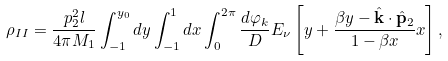<formula> <loc_0><loc_0><loc_500><loc_500>\rho _ { I I } = \frac { p _ { 2 } ^ { 2 } l } { 4 \pi M _ { 1 } } \int _ { - 1 } ^ { y _ { 0 } } d y \int _ { - 1 } ^ { 1 } d x \int _ { 0 } ^ { 2 \pi } \frac { d \varphi _ { k } } { D } E _ { \nu } \left [ y + \frac { \beta y - { \hat { \mathbf k } } \cdot { \hat { \mathbf p } _ { 2 } } } { 1 - \beta x } x \right ] ,</formula> 